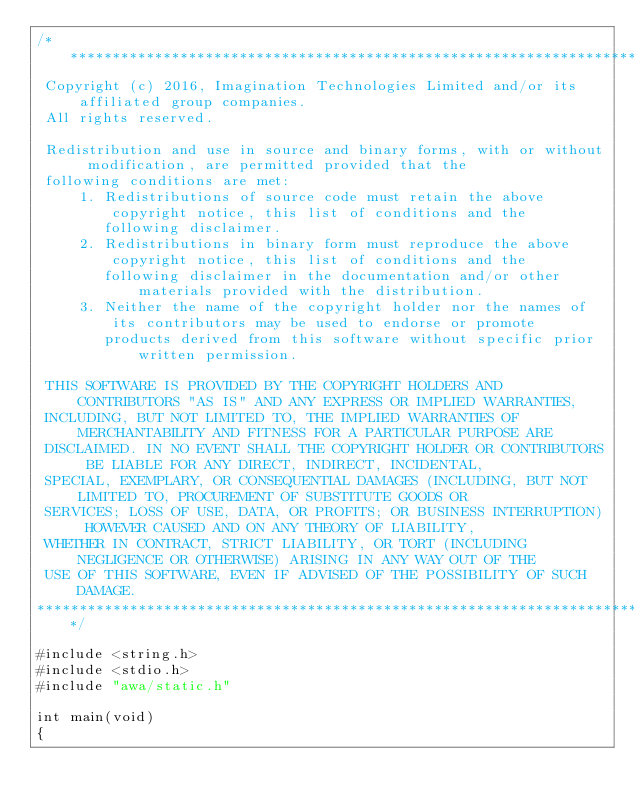Convert code to text. <code><loc_0><loc_0><loc_500><loc_500><_C_>/************************************************************************************************************************
 Copyright (c) 2016, Imagination Technologies Limited and/or its affiliated group companies.
 All rights reserved.

 Redistribution and use in source and binary forms, with or without modification, are permitted provided that the
 following conditions are met:
     1. Redistributions of source code must retain the above copyright notice, this list of conditions and the
        following disclaimer.
     2. Redistributions in binary form must reproduce the above copyright notice, this list of conditions and the
        following disclaimer in the documentation and/or other materials provided with the distribution.
     3. Neither the name of the copyright holder nor the names of its contributors may be used to endorse or promote
        products derived from this software without specific prior written permission.

 THIS SOFTWARE IS PROVIDED BY THE COPYRIGHT HOLDERS AND CONTRIBUTORS "AS IS" AND ANY EXPRESS OR IMPLIED WARRANTIES,
 INCLUDING, BUT NOT LIMITED TO, THE IMPLIED WARRANTIES OF MERCHANTABILITY AND FITNESS FOR A PARTICULAR PURPOSE ARE
 DISCLAIMED. IN NO EVENT SHALL THE COPYRIGHT HOLDER OR CONTRIBUTORS BE LIABLE FOR ANY DIRECT, INDIRECT, INCIDENTAL, 
 SPECIAL, EXEMPLARY, OR CONSEQUENTIAL DAMAGES (INCLUDING, BUT NOT LIMITED TO, PROCUREMENT OF SUBSTITUTE GOODS OR
 SERVICES; LOSS OF USE, DATA, OR PROFITS; OR BUSINESS INTERRUPTION) HOWEVER CAUSED AND ON ANY THEORY OF LIABILITY, 
 WHETHER IN CONTRACT, STRICT LIABILITY, OR TORT (INCLUDING NEGLIGENCE OR OTHERWISE) ARISING IN ANY WAY OUT OF THE 
 USE OF THIS SOFTWARE, EVEN IF ADVISED OF THE POSSIBILITY OF SUCH DAMAGE.
************************************************************************************************************************/

#include <string.h>
#include <stdio.h>
#include "awa/static.h"

int main(void)
{</code> 